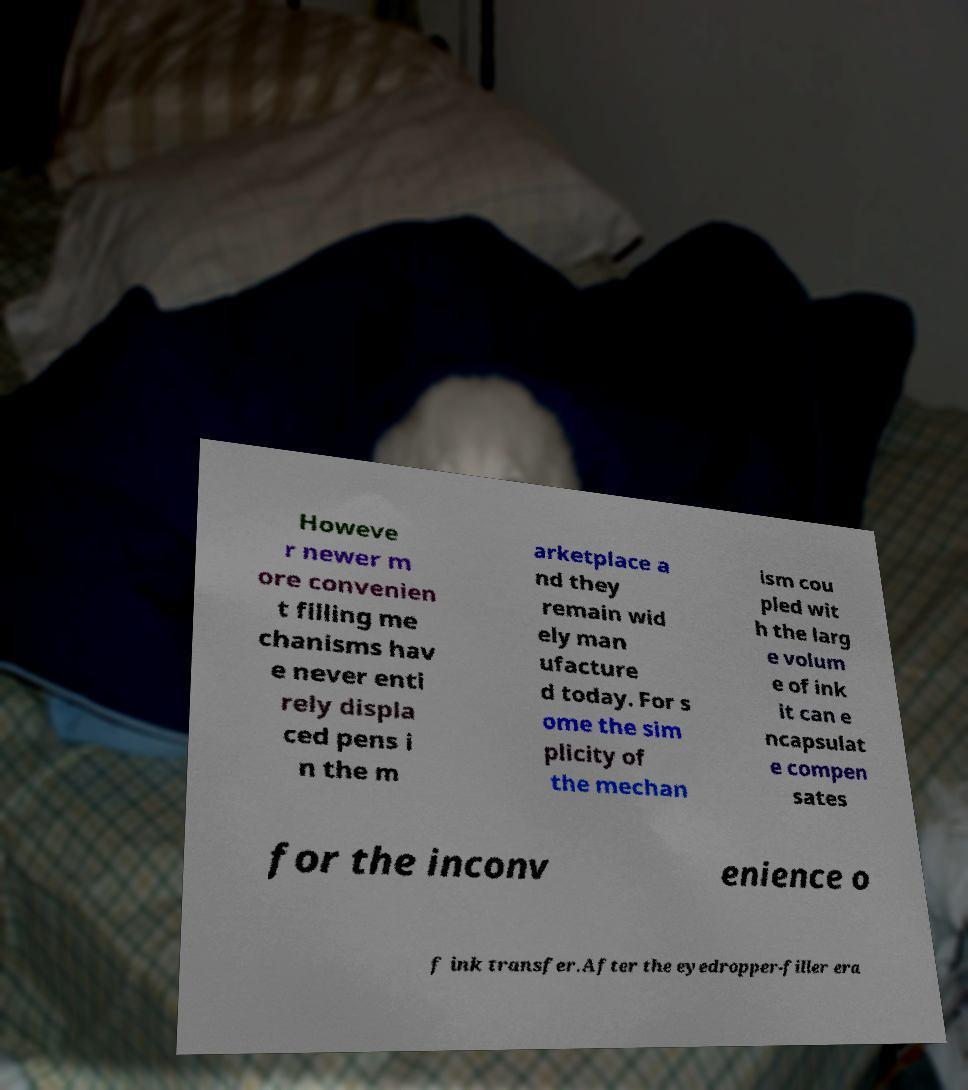Please identify and transcribe the text found in this image. Howeve r newer m ore convenien t filling me chanisms hav e never enti rely displa ced pens i n the m arketplace a nd they remain wid ely man ufacture d today. For s ome the sim plicity of the mechan ism cou pled wit h the larg e volum e of ink it can e ncapsulat e compen sates for the inconv enience o f ink transfer.After the eyedropper-filler era 